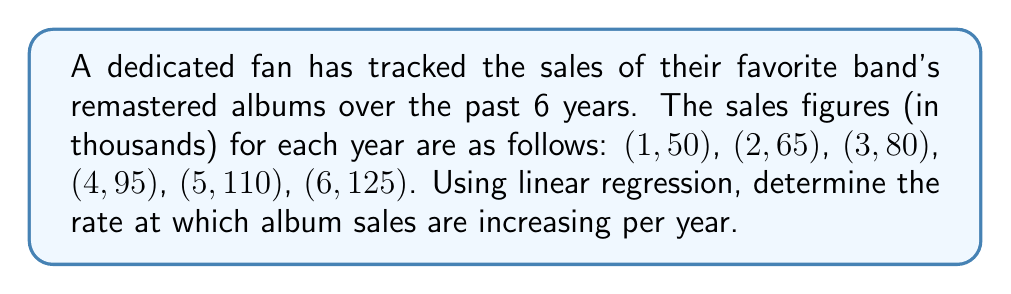Show me your answer to this math problem. To find the rate of album sales increase using linear regression, we'll follow these steps:

1. Let $x$ represent the year and $y$ represent the sales in thousands.

2. Calculate the means of $x$ and $y$:
   $\bar{x} = \frac{1+2+3+4+5+6}{6} = 3.5$
   $\bar{y} = \frac{50+65+80+95+110+125}{6} = 87.5$

3. Calculate $\sum(x - \bar{x})(y - \bar{y})$ and $\sum(x - \bar{x})^2$:

   $$\sum(x - \bar{x})(y - \bar{y}) = (-2.5)(-37.5) + (-1.5)(-22.5) + (-0.5)(-7.5) + (0.5)(7.5) + (1.5)(22.5) + (2.5)(37.5) = 187.5$$

   $$\sum(x - \bar{x})^2 = (-2.5)^2 + (-1.5)^2 + (-0.5)^2 + (0.5)^2 + (1.5)^2 + (2.5)^2 = 17.5$$

4. Calculate the slope (m) of the regression line:
   $$m = \frac{\sum(x - \bar{x})(y - \bar{y})}{\sum(x - \bar{x})^2} = \frac{187.5}{17.5} = 10.71$$

The slope represents the rate of increase in album sales per year.
Answer: $10.71$ thousand per year 